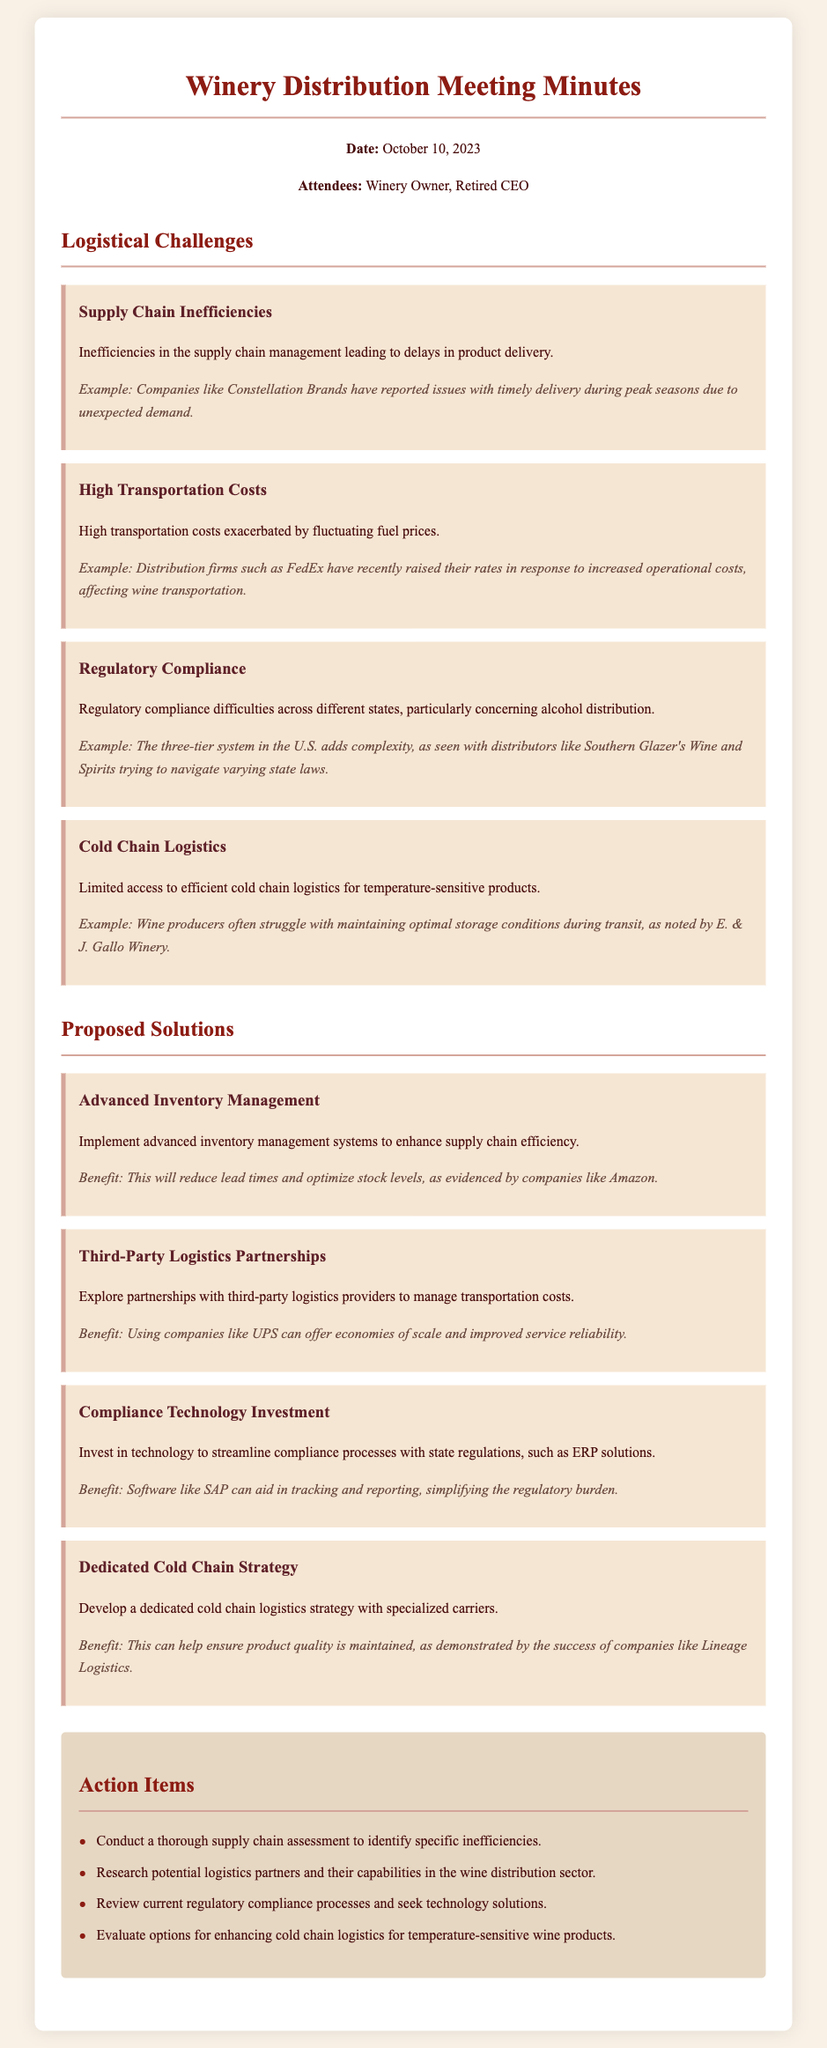What is the date of the meeting? The date of the meeting is provided in the header section of the document.
Answer: October 10, 2023 Who are the attendees of the meeting? The attendees are listed in the header section of the meeting minutes.
Answer: Winery Owner, Retired CEO What is one logistical challenge regarding supply chain management? The document lists several logistical challenges, particularly supply chain inefficiencies.
Answer: Supply Chain Inefficiencies What company is mentioned as having issues with timely delivery during peak seasons? The example given highlights a company facing this issue as part of the logistical challenges.
Answer: Constellation Brands What is a proposed solution for high transportation costs? The document suggests exploring partnerships with third-party logistics providers.
Answer: Third-Party Logistics Partnerships Which technology is recommended for streamlining compliance processes? The meeting minutes mention an investment in certain software to aid compliance.
Answer: SAP What is one benefit of a dedicated cold chain logistics strategy? The document provides benefits associated with developing this strategy.
Answer: Ensuring product quality What action item involves researching logistics partners? There is a clear action item mentioned regarding logistics partners in the last section of the minutes.
Answer: Research potential logistics partners Which company is referenced as a successful example of cold chain logistics? The document provides an example of a company that has successfully implemented cold chain logistics.
Answer: Lineage Logistics 